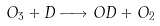<formula> <loc_0><loc_0><loc_500><loc_500>O _ { 3 } + D \longrightarrow O D + O _ { 2 }</formula> 